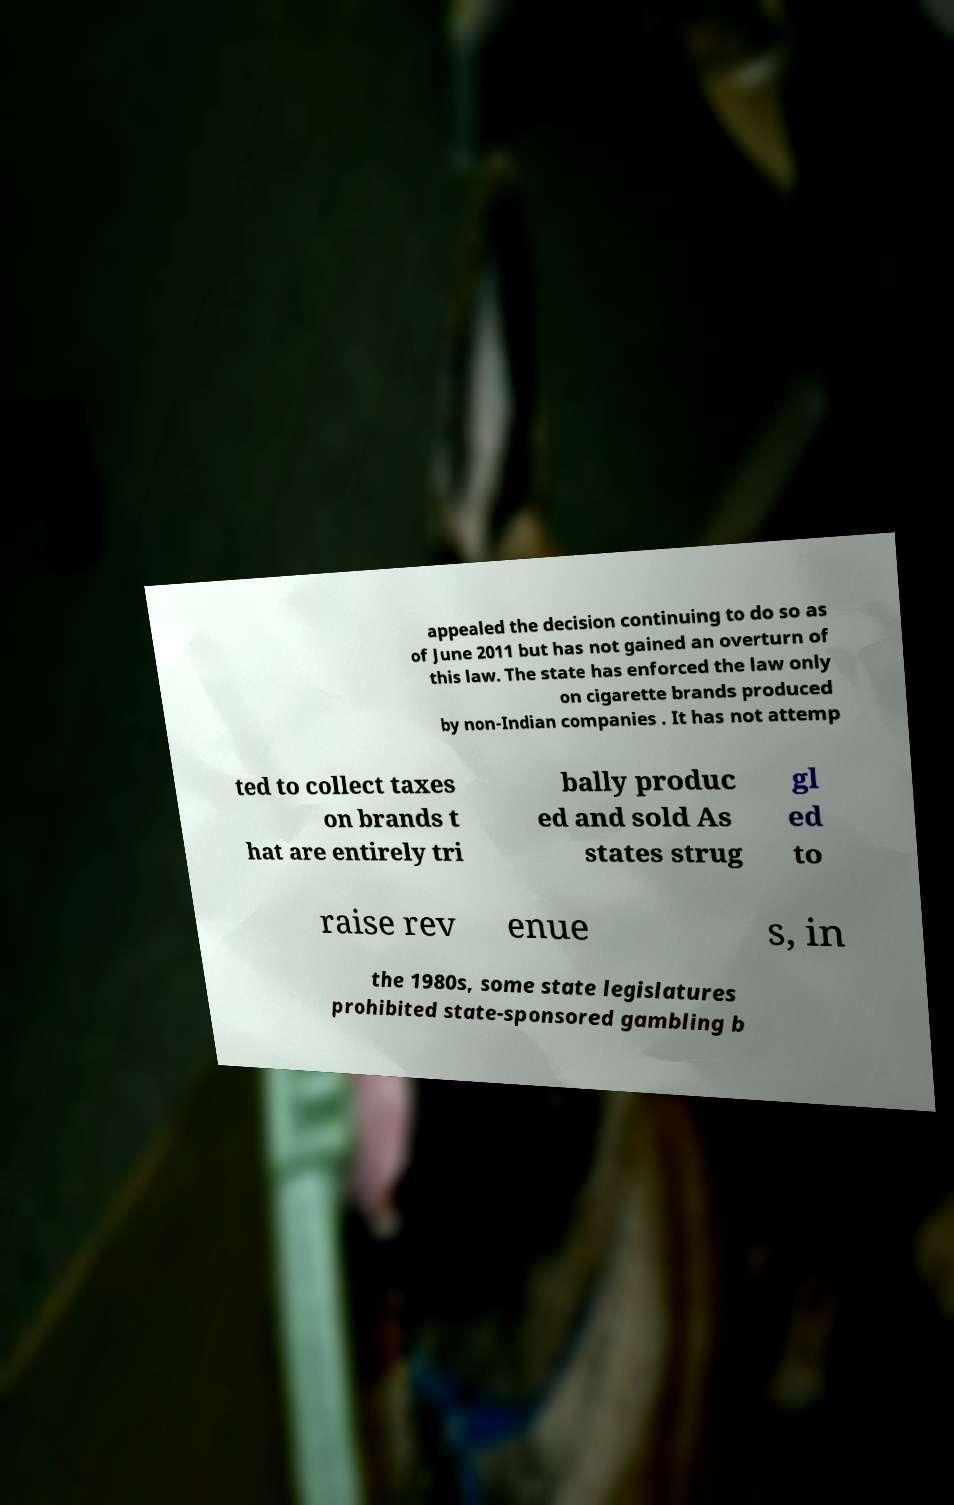Could you assist in decoding the text presented in this image and type it out clearly? appealed the decision continuing to do so as of June 2011 but has not gained an overturn of this law. The state has enforced the law only on cigarette brands produced by non-Indian companies . It has not attemp ted to collect taxes on brands t hat are entirely tri bally produc ed and sold As states strug gl ed to raise rev enue s, in the 1980s, some state legislatures prohibited state-sponsored gambling b 